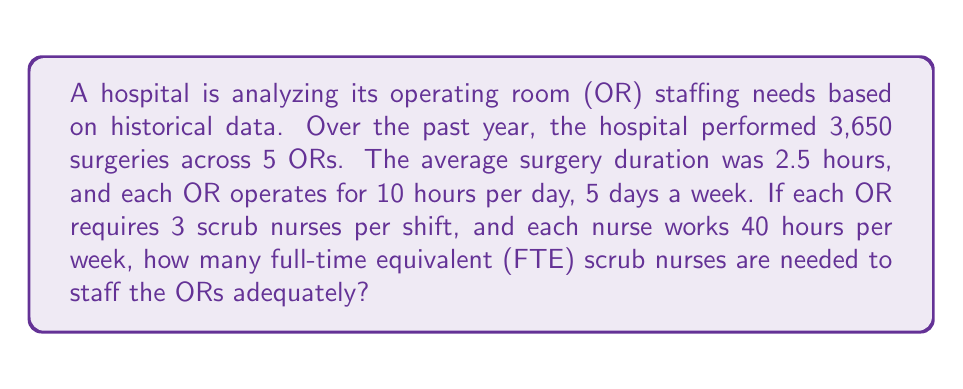Could you help me with this problem? Let's break this down step-by-step:

1. Calculate the total OR hours per year:
   $$\text{Total OR hours} = 5 \text{ ORs} \times 10 \text{ hours/day} \times 5 \text{ days/week} \times 52 \text{ weeks/year} = 13,000 \text{ hours/year}$$

2. Calculate the total surgery hours per year:
   $$\text{Total surgery hours} = 3,650 \text{ surgeries} \times 2.5 \text{ hours/surgery} = 9,125 \text{ hours/year}$$

3. Calculate the OR utilization rate:
   $$\text{Utilization rate} = \frac{9,125 \text{ hours}}{13,000 \text{ hours}} \approx 0.7019 \text{ or } 70.19\%$$

4. Calculate the number of nurse-hours needed per year:
   $$\text{Nurse-hours needed} = 13,000 \text{ OR hours} \times 3 \text{ nurses/OR} = 39,000 \text{ nurse-hours/year}$$

5. Calculate the number of hours one FTE nurse works per year:
   $$\text{FTE nurse hours} = 40 \text{ hours/week} \times 52 \text{ weeks/year} = 2,080 \text{ hours/year}$$

6. Calculate the number of FTE nurses needed:
   $$\text{FTE nurses needed} = \frac{39,000 \text{ nurse-hours/year}}{2,080 \text{ hours/nurse/year}} \approx 18.75 \text{ FTE nurses}$$

7. Round up to the nearest whole number to ensure adequate staffing:
   $$\text{FTE nurses needed (rounded)} = 19 \text{ FTE nurses}$$
Answer: 19 FTE nurses 